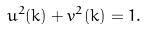<formula> <loc_0><loc_0><loc_500><loc_500>u ^ { 2 } ( { k } ) + v ^ { 2 } ( { k } ) = 1 .</formula> 